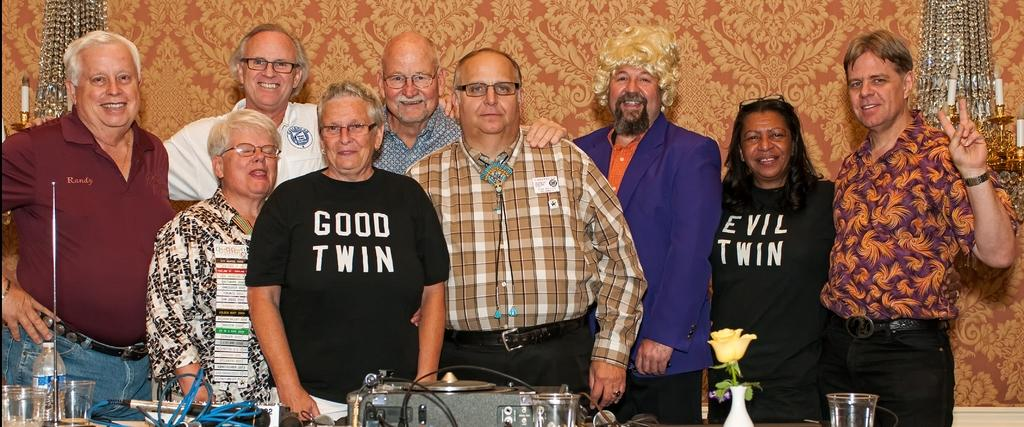What is happening in the center of the image? There are people standing in the center of the image. What is in front of the people? There is a table in front of the people. What can be seen on the table? There are glasses on the table. Are there any other items on the table besides the glasses? Yes, there are other items on the table. What type of produce is being harvested by the people in the image? There is no produce or harvesting activity depicted in the image. What kind of shock can be seen affecting the people in the image? There is no shock or any indication of an electrical or emotional shock in the image. 